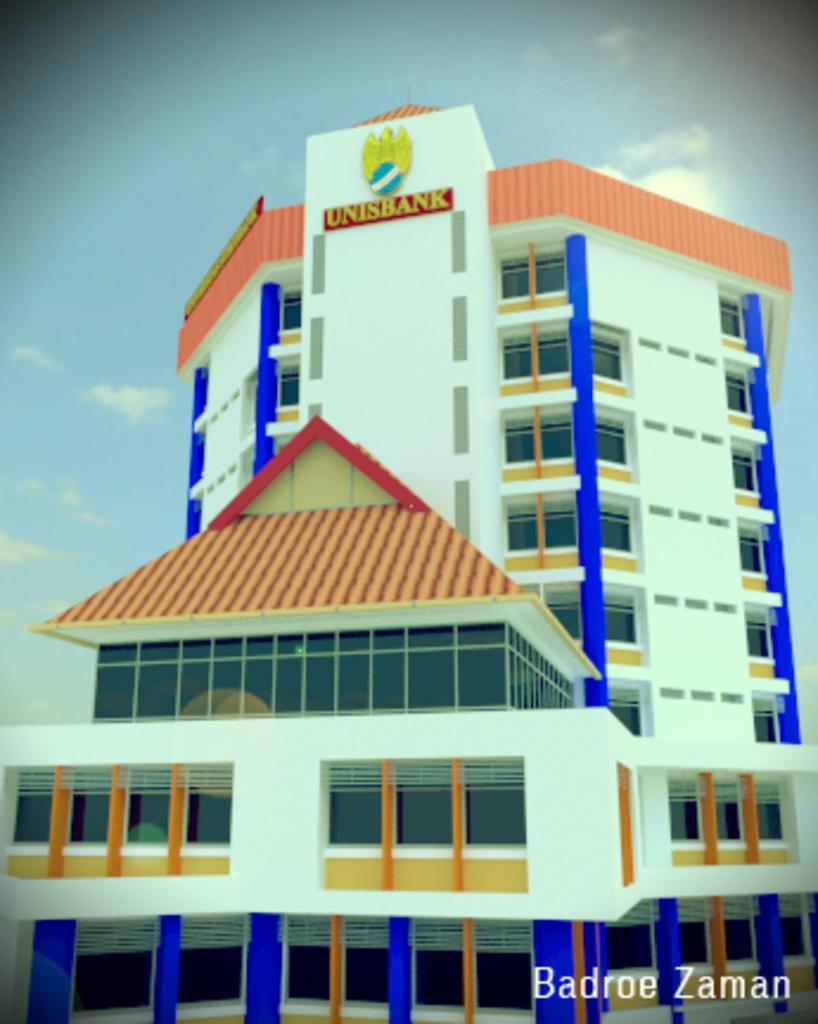What type of structure is in the image? There is a building in the image. What is written on the board attached to the building? The board has the name "UNIS BANK" on it. What can be seen in the sky in the image? The sky is visible in the image, and clouds are present. What is the name of the bank that is being smashed in the image? There is no mention of a bank being smashed in the image. 